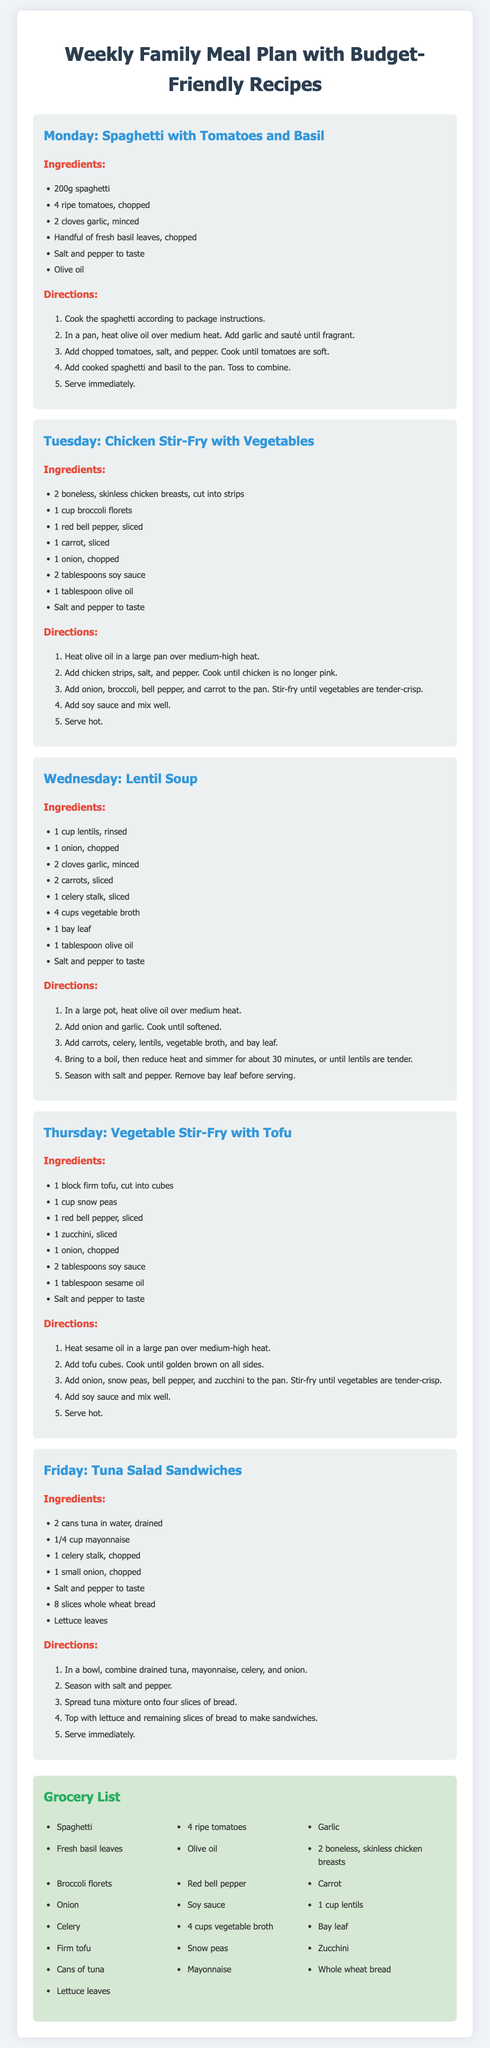What is the first meal listed for Monday? The document lists "Spaghetti with Tomatoes and Basil" as the first meal for Monday.
Answer: Spaghetti with Tomatoes and Basil How many cups of vegetable broth are needed for the Lentil Soup? The recipe for Lentil Soup indicates that 4 cups of vegetable broth are needed.
Answer: 4 cups What ingredients are used in the Tuna Salad Sandwiches? The Tuna Salad Sandwiches consist of tuna, mayonnaise, celery, onion, salt, pepper, whole wheat bread, and lettuce leaves.
Answer: tuna, mayonnaise, celery, onion, salt, pepper, whole wheat bread, lettuce leaves How many ingredients are listed for the Vegetable Stir-Fry with Tofu? The Vegetable Stir-Fry with Tofu lists 8 ingredients.
Answer: 8 ingredients What is the cooking method used for the Chicken Stir-Fry? The Chicken Stir-Fry is prepared using the stir-frying method.
Answer: Stir-fry How many days are included in the meal plan? The meal plan includes a total of 5 days.
Answer: 5 days What is the main protein source in the dish for Thursday? The main protein source in the Vegetable Stir-Fry with Tofu is tofu.
Answer: Tofu What type of oil is used in the recipes? Olive oil is frequently used in the recipes within the meal plan.
Answer: Olive oil 